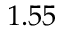Convert formula to latex. <formula><loc_0><loc_0><loc_500><loc_500>1 . 5 5</formula> 